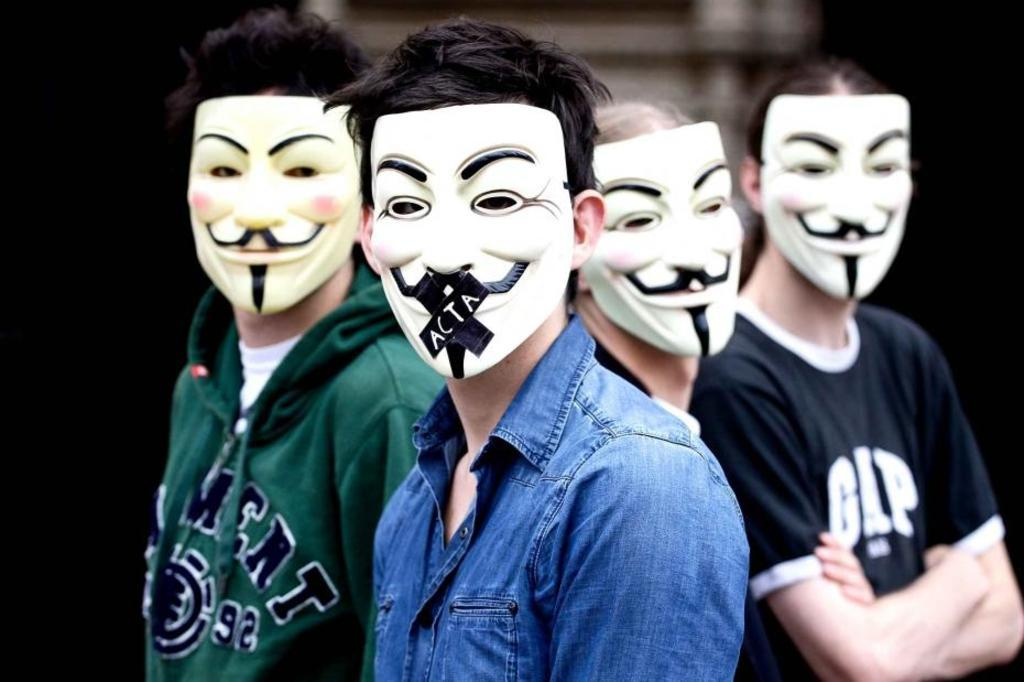Who or what can be seen in the image? There are people in the image. What are the people wearing on their faces? The people are wearing masks. Can you describe the background of the image? The background of the image is blurred. What type of bun is being served by the manager in the image? There is no manager or bun present in the image. 